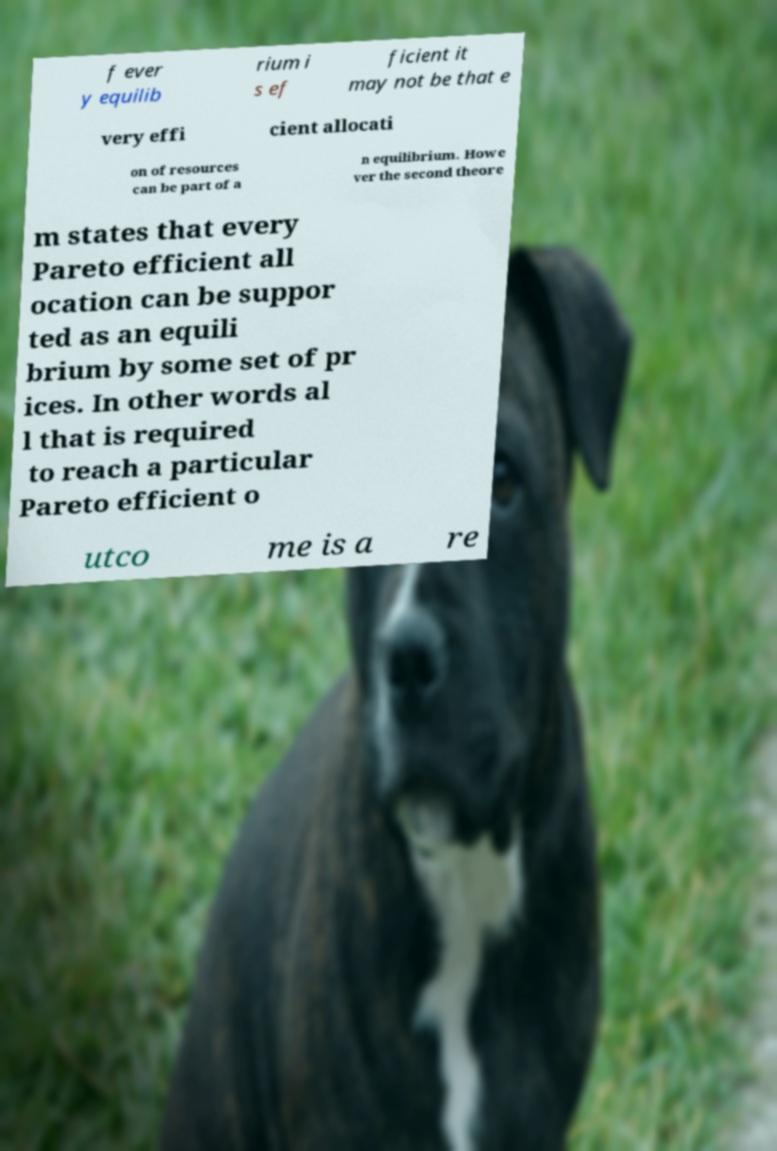Please identify and transcribe the text found in this image. f ever y equilib rium i s ef ficient it may not be that e very effi cient allocati on of resources can be part of a n equilibrium. Howe ver the second theore m states that every Pareto efficient all ocation can be suppor ted as an equili brium by some set of pr ices. In other words al l that is required to reach a particular Pareto efficient o utco me is a re 